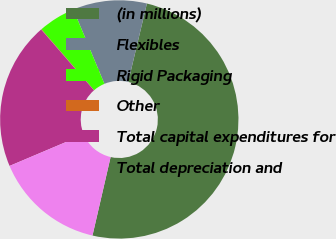Convert chart to OTSL. <chart><loc_0><loc_0><loc_500><loc_500><pie_chart><fcel>(in millions)<fcel>Flexibles<fcel>Rigid Packaging<fcel>Other<fcel>Total capital expenditures for<fcel>Total depreciation and<nl><fcel>49.89%<fcel>10.02%<fcel>5.04%<fcel>0.05%<fcel>19.99%<fcel>15.01%<nl></chart> 